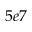Convert formula to latex. <formula><loc_0><loc_0><loc_500><loc_500>5 e 7</formula> 